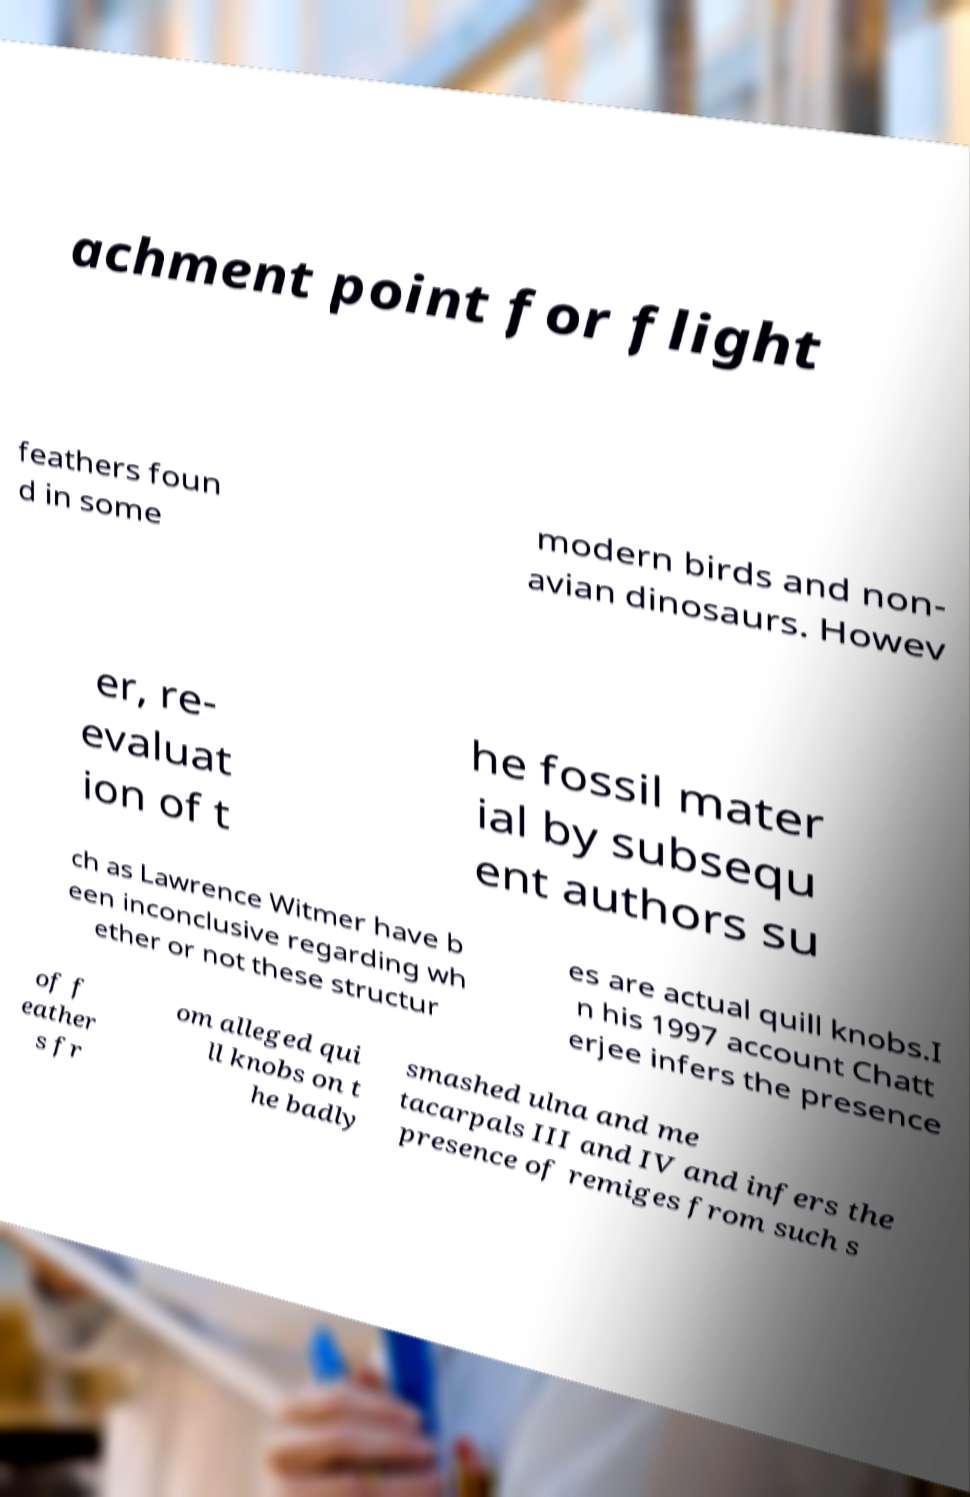For documentation purposes, I need the text within this image transcribed. Could you provide that? achment point for flight feathers foun d in some modern birds and non- avian dinosaurs. Howev er, re- evaluat ion of t he fossil mater ial by subsequ ent authors su ch as Lawrence Witmer have b een inconclusive regarding wh ether or not these structur es are actual quill knobs.I n his 1997 account Chatt erjee infers the presence of f eather s fr om alleged qui ll knobs on t he badly smashed ulna and me tacarpals III and IV and infers the presence of remiges from such s 